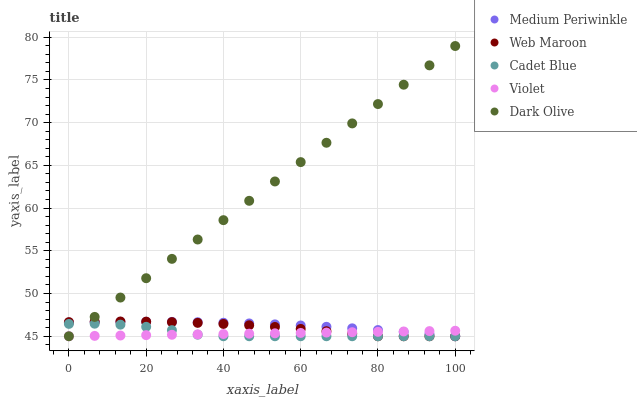Does Violet have the minimum area under the curve?
Answer yes or no. Yes. Does Dark Olive have the maximum area under the curve?
Answer yes or no. Yes. Does Web Maroon have the minimum area under the curve?
Answer yes or no. No. Does Web Maroon have the maximum area under the curve?
Answer yes or no. No. Is Violet the smoothest?
Answer yes or no. Yes. Is Cadet Blue the roughest?
Answer yes or no. Yes. Is Web Maroon the smoothest?
Answer yes or no. No. Is Web Maroon the roughest?
Answer yes or no. No. Does Dark Olive have the lowest value?
Answer yes or no. Yes. Does Dark Olive have the highest value?
Answer yes or no. Yes. Does Web Maroon have the highest value?
Answer yes or no. No. Does Violet intersect Cadet Blue?
Answer yes or no. Yes. Is Violet less than Cadet Blue?
Answer yes or no. No. Is Violet greater than Cadet Blue?
Answer yes or no. No. 